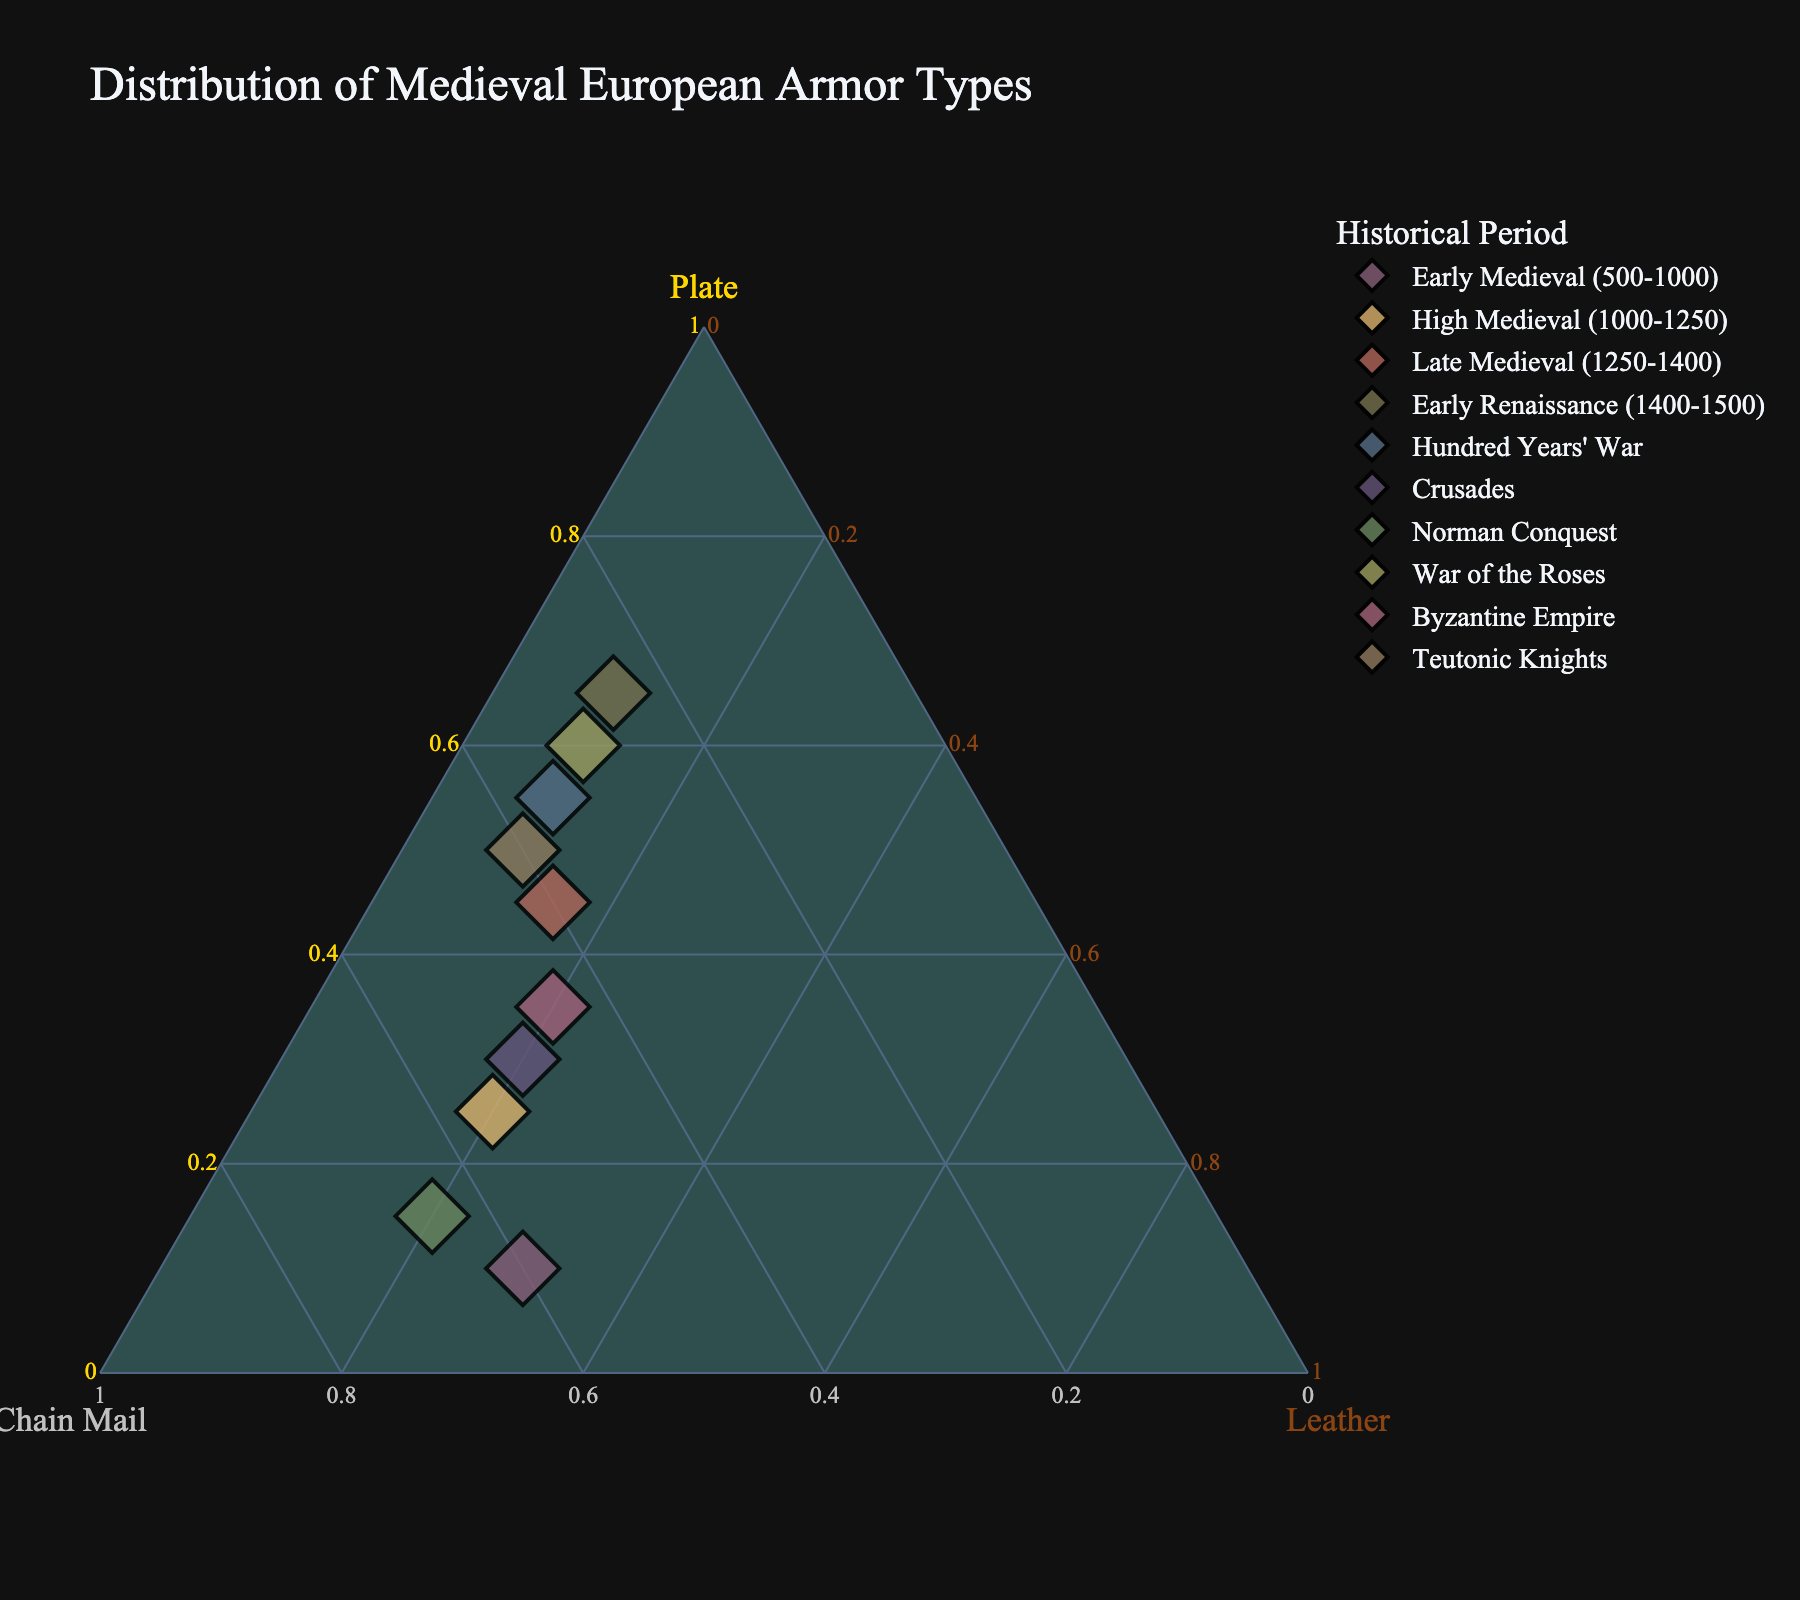What is the title of the figure? The title of the figure can be seen at the top and reads "Distribution of Medieval European Armor Types."
Answer: Distribution of Medieval European Armor Types How many periods are represented in the plot? The number of periods can be counted by looking at the unique hover names for each data point or by counting the distinct colors/symbols used.
Answer: 10 Which period has the highest proportion of Plate armor? By locating the point furthest towards the "Plate" axis in the ternary plot, we can determine that the Early Renaissance period has the highest proportion of Plate armor.
Answer: Early Renaissance Which two periods have the same proportion of Leather armor? Observing the plot, the points with the same coordinate along the "Leather" axis are Early Renaissance and High Medieval periods.
Answer: Early Renaissance and High Medieval What's the total percentage of Chain Mail armor across all periods? Sum the percentages of Chain Mail armor from all periods. \(60 + 55 + 40 + 25 + 35 + 50 + 65 + 30 + 45 + 40\) = 445%
Answer: 445% Which period has the closest distribution of armor types? The period where the point is closest to the center of the ternary plot indicates a more balanced distribution among Plate, Chain Mail, and Leather armor. This is the Byzantine Empire period.
Answer: Byzantine Empire Compare the proportion of Plate armor between the Early Medieval and the Late Medieval periods. Which is larger and by how much? The proportion of Plate armor in the Early Medieval period is 10%, and in the Late Medieval period is 45%. \(45 - 10\) = 35%.
Answer: Late Medieval, by 35% Which period shows the most dominance of Chain Mail over Plate armor? Look for the period where the point is as far to the "ChainMail" axis and away from "Plate" as possible. The Norman Conquest period shows the most dominance of Chain Mail over Plate armor at 65% vs. 15%.
Answer: Norman Conquest Between the War of the Roses and the Hundred Years' War, which period has a higher proportion of Leather armor? By observing their respective positions along the "Leather" axis, the Hundred Years' War period has 10% while the War of the Roses has 10%. Both have the same proportion of Leather armor.
Answer: Both equal at 10% What's the average percentage of Chain Mail armor during the Crusades and the Teutonic Knights periods? Calculate the average of the Chain Mail values for these periods. \(\frac{(50 + 40)}{2} = 45\)%.
Answer: 45% 